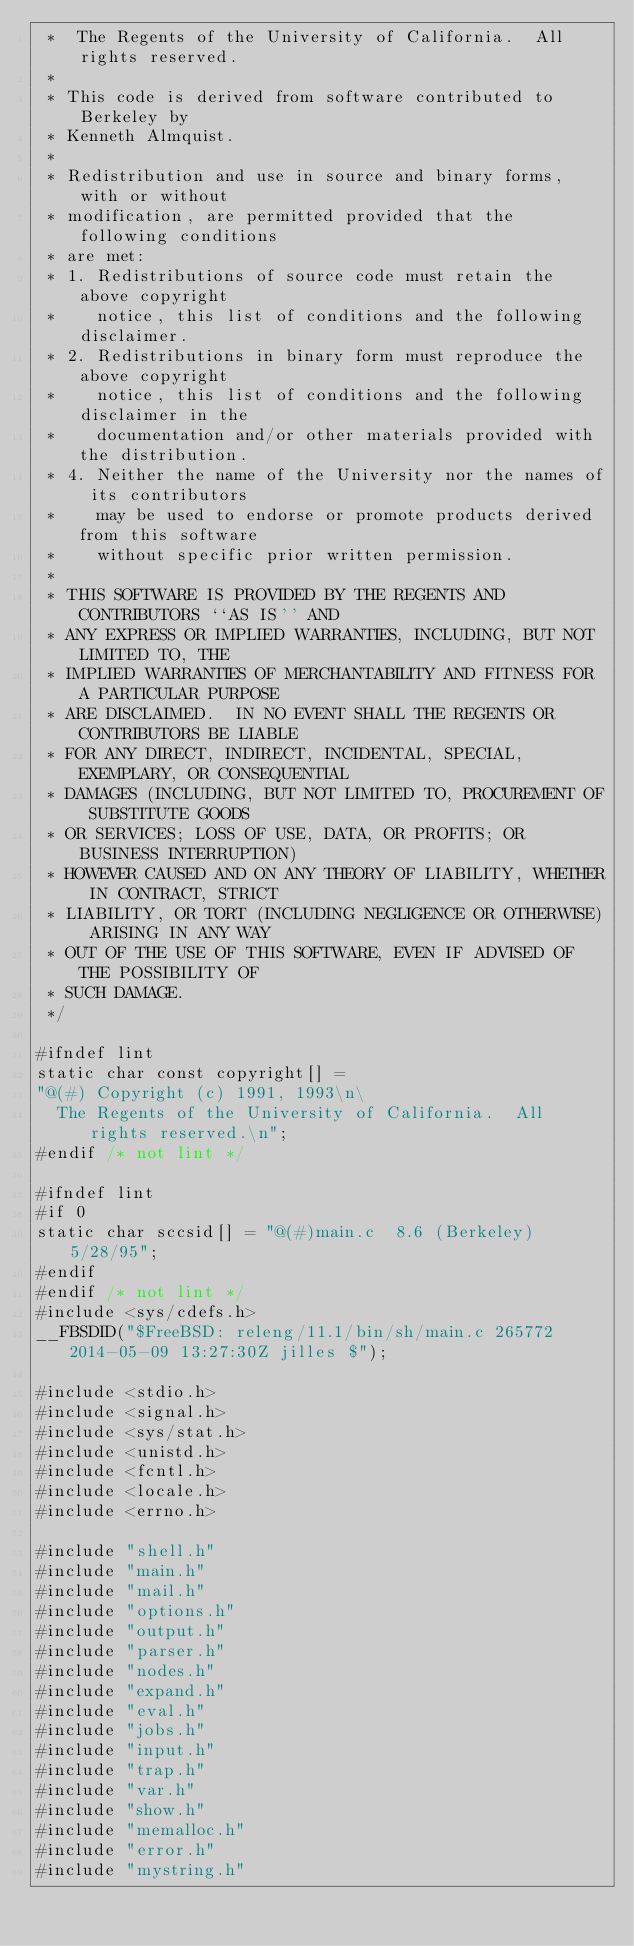Convert code to text. <code><loc_0><loc_0><loc_500><loc_500><_C_> *	The Regents of the University of California.  All rights reserved.
 *
 * This code is derived from software contributed to Berkeley by
 * Kenneth Almquist.
 *
 * Redistribution and use in source and binary forms, with or without
 * modification, are permitted provided that the following conditions
 * are met:
 * 1. Redistributions of source code must retain the above copyright
 *    notice, this list of conditions and the following disclaimer.
 * 2. Redistributions in binary form must reproduce the above copyright
 *    notice, this list of conditions and the following disclaimer in the
 *    documentation and/or other materials provided with the distribution.
 * 4. Neither the name of the University nor the names of its contributors
 *    may be used to endorse or promote products derived from this software
 *    without specific prior written permission.
 *
 * THIS SOFTWARE IS PROVIDED BY THE REGENTS AND CONTRIBUTORS ``AS IS'' AND
 * ANY EXPRESS OR IMPLIED WARRANTIES, INCLUDING, BUT NOT LIMITED TO, THE
 * IMPLIED WARRANTIES OF MERCHANTABILITY AND FITNESS FOR A PARTICULAR PURPOSE
 * ARE DISCLAIMED.  IN NO EVENT SHALL THE REGENTS OR CONTRIBUTORS BE LIABLE
 * FOR ANY DIRECT, INDIRECT, INCIDENTAL, SPECIAL, EXEMPLARY, OR CONSEQUENTIAL
 * DAMAGES (INCLUDING, BUT NOT LIMITED TO, PROCUREMENT OF SUBSTITUTE GOODS
 * OR SERVICES; LOSS OF USE, DATA, OR PROFITS; OR BUSINESS INTERRUPTION)
 * HOWEVER CAUSED AND ON ANY THEORY OF LIABILITY, WHETHER IN CONTRACT, STRICT
 * LIABILITY, OR TORT (INCLUDING NEGLIGENCE OR OTHERWISE) ARISING IN ANY WAY
 * OUT OF THE USE OF THIS SOFTWARE, EVEN IF ADVISED OF THE POSSIBILITY OF
 * SUCH DAMAGE.
 */

#ifndef lint
static char const copyright[] =
"@(#) Copyright (c) 1991, 1993\n\
	The Regents of the University of California.  All rights reserved.\n";
#endif /* not lint */

#ifndef lint
#if 0
static char sccsid[] = "@(#)main.c	8.6 (Berkeley) 5/28/95";
#endif
#endif /* not lint */
#include <sys/cdefs.h>
__FBSDID("$FreeBSD: releng/11.1/bin/sh/main.c 265772 2014-05-09 13:27:30Z jilles $");

#include <stdio.h>
#include <signal.h>
#include <sys/stat.h>
#include <unistd.h>
#include <fcntl.h>
#include <locale.h>
#include <errno.h>

#include "shell.h"
#include "main.h"
#include "mail.h"
#include "options.h"
#include "output.h"
#include "parser.h"
#include "nodes.h"
#include "expand.h"
#include "eval.h"
#include "jobs.h"
#include "input.h"
#include "trap.h"
#include "var.h"
#include "show.h"
#include "memalloc.h"
#include "error.h"
#include "mystring.h"</code> 